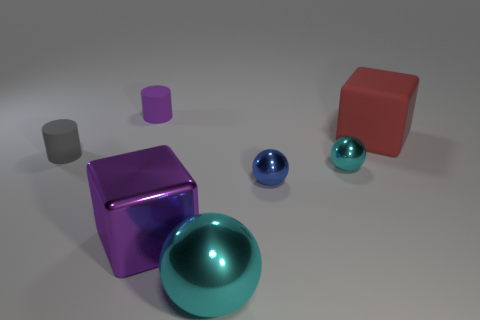Add 3 tiny red things. How many objects exist? 10 Subtract all cylinders. How many objects are left? 5 Subtract all matte cylinders. Subtract all metal spheres. How many objects are left? 2 Add 2 spheres. How many spheres are left? 5 Add 5 small yellow cubes. How many small yellow cubes exist? 5 Subtract 0 cyan blocks. How many objects are left? 7 